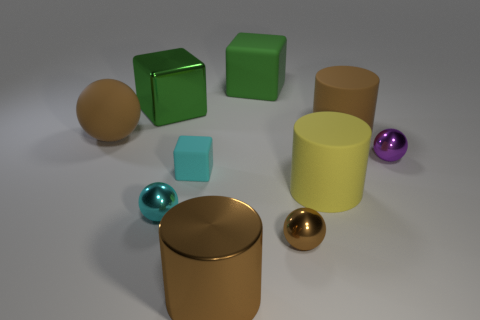Subtract all cubes. How many objects are left? 7 Add 4 small cyan metallic cylinders. How many small cyan metallic cylinders exist? 4 Subtract 1 cyan spheres. How many objects are left? 9 Subtract all yellow things. Subtract all small red balls. How many objects are left? 9 Add 8 big green matte blocks. How many big green matte blocks are left? 9 